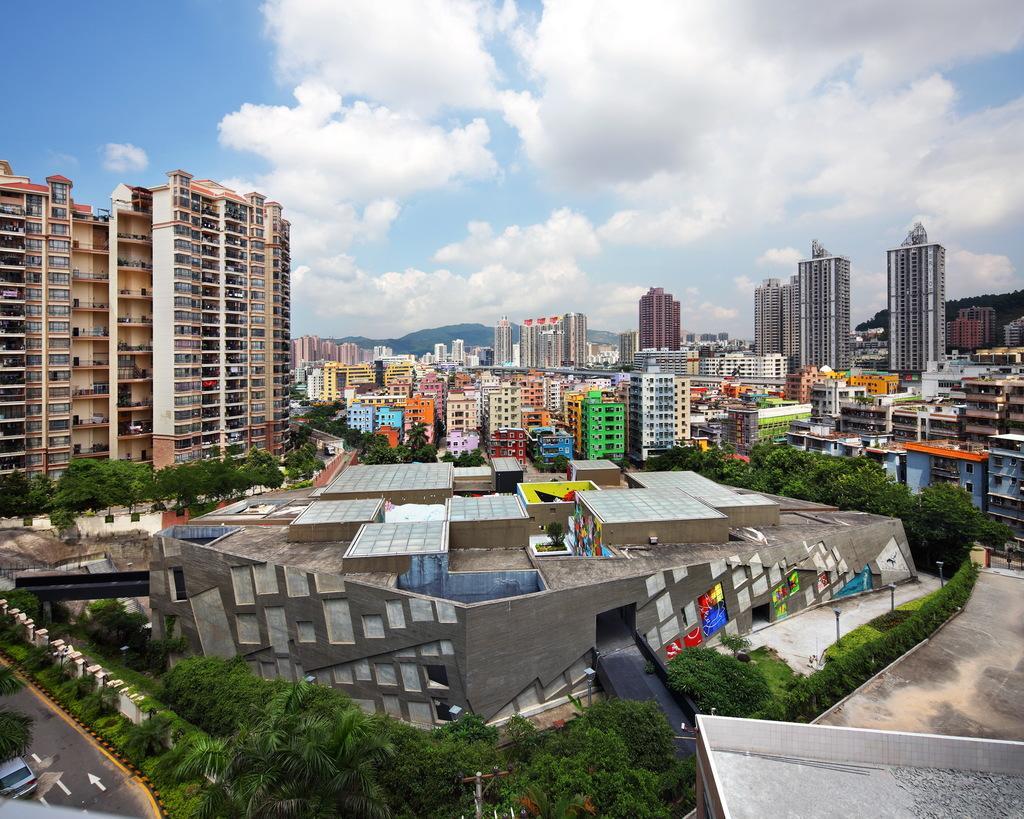How would you summarize this image in a sentence or two? On the left side of the image there is a car on the road. There are trees, buildings, plants. At the top of the image there are clouds in the sky. 